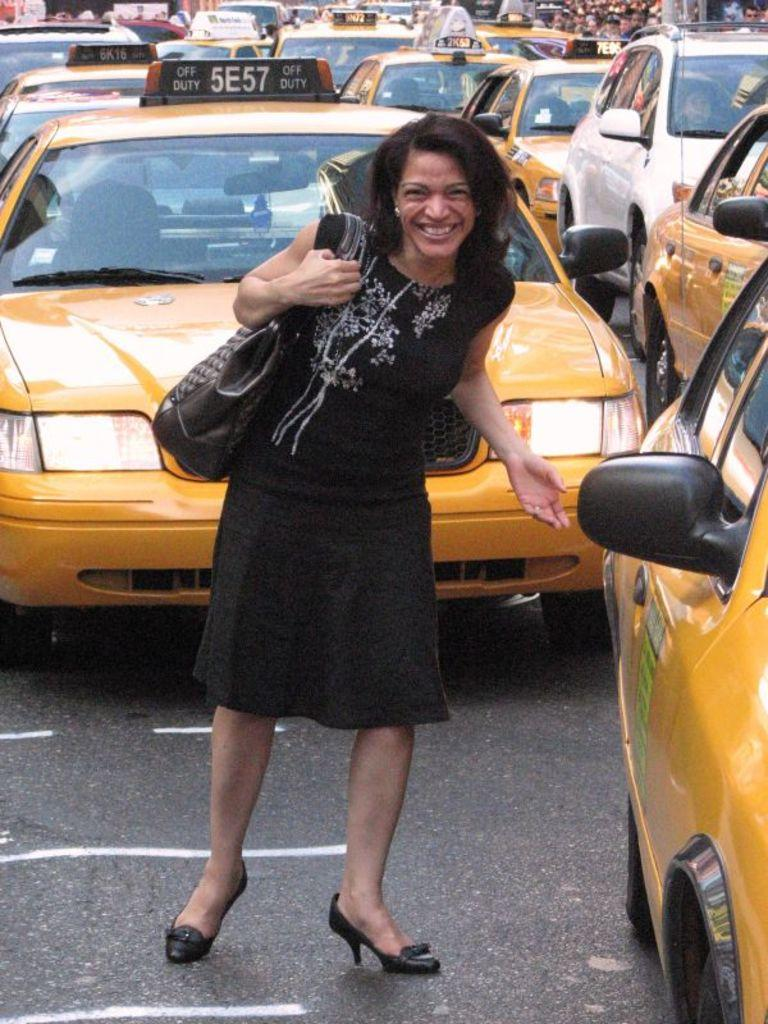<image>
Summarize the visual content of the image. A woman standing infront of a taxi number 5E57 